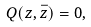Convert formula to latex. <formula><loc_0><loc_0><loc_500><loc_500>Q ( z , \bar { z } ) = 0 ,</formula> 